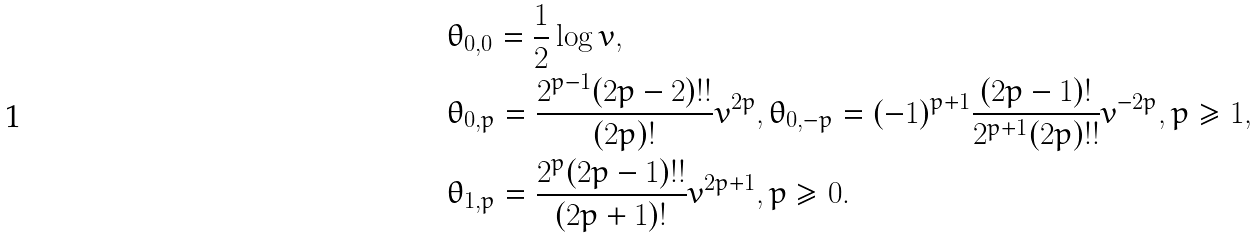Convert formula to latex. <formula><loc_0><loc_0><loc_500><loc_500>& \theta _ { 0 , 0 } = \frac { 1 } { 2 } \log v , \\ & \theta _ { 0 , p } = \frac { 2 ^ { p - 1 } ( 2 p - 2 ) ! ! } { ( 2 p ) ! } v ^ { 2 p } , \theta _ { 0 , - p } = ( - 1 ) ^ { p + 1 } \frac { ( 2 p - 1 ) ! } { 2 ^ { p + 1 } ( 2 p ) ! ! } v ^ { - 2 p } , p \geq 1 , \\ & \theta _ { 1 , p } = \frac { 2 ^ { p } ( 2 p - 1 ) ! ! } { ( 2 p + 1 ) ! } v ^ { 2 p + 1 } , p \geq 0 .</formula> 